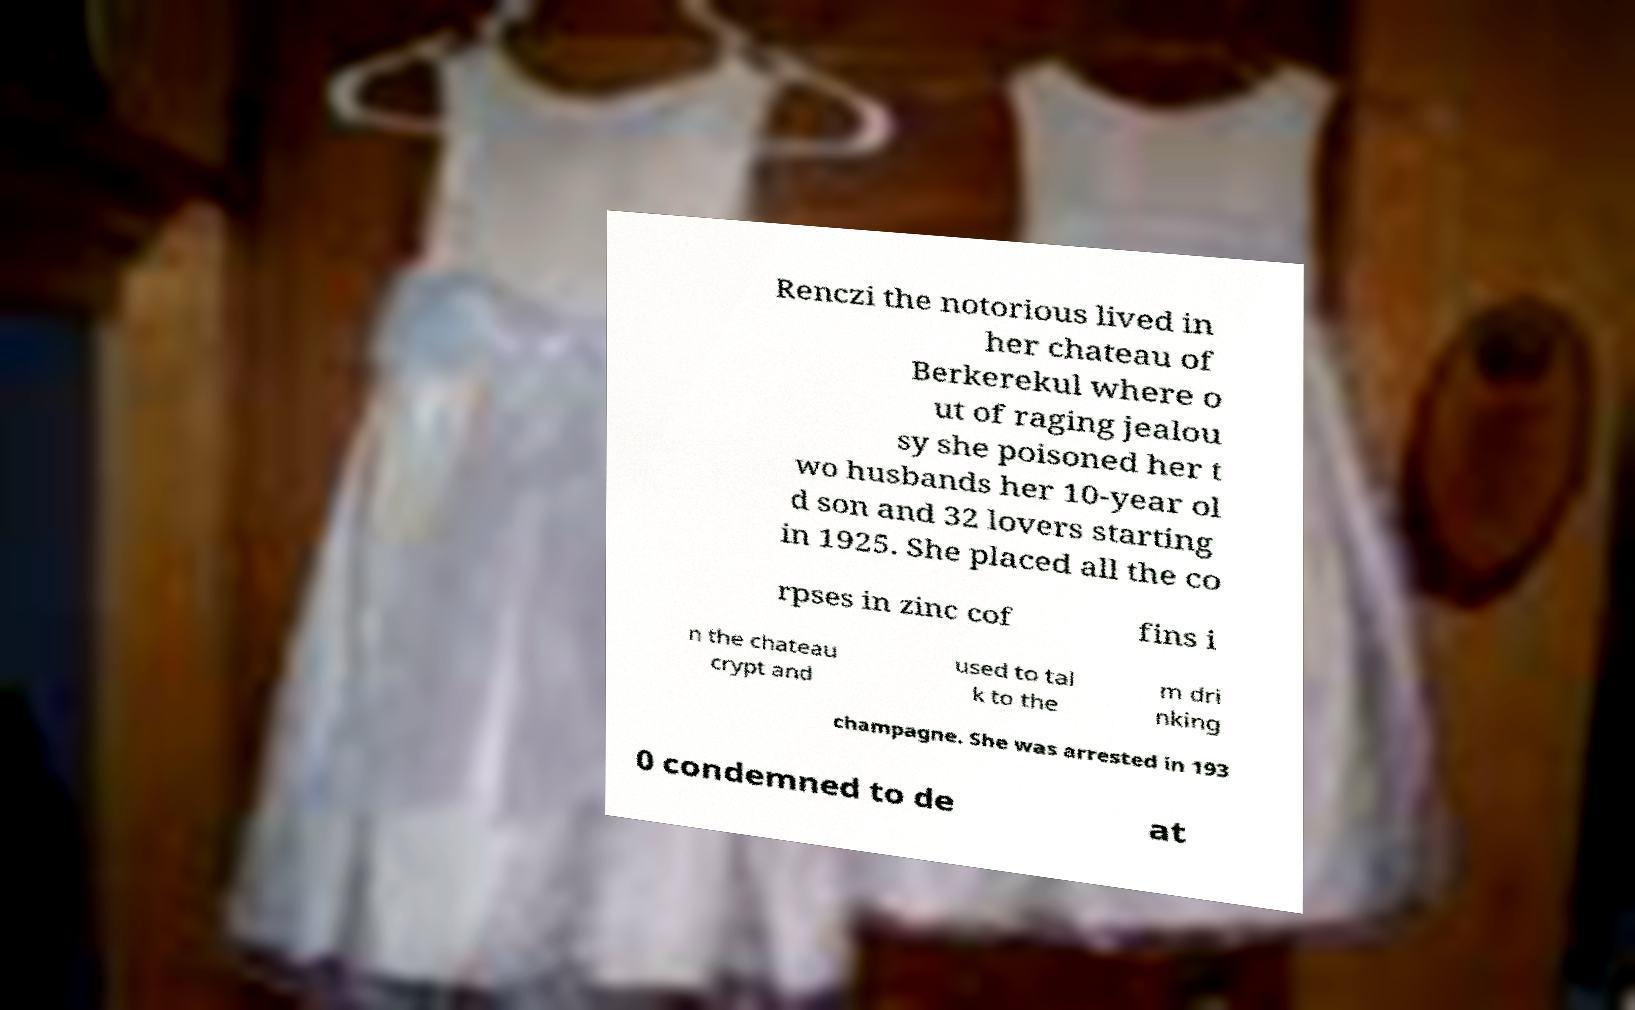What messages or text are displayed in this image? I need them in a readable, typed format. Renczi the notorious lived in her chateau of Berkerekul where o ut of raging jealou sy she poisoned her t wo husbands her 10-year ol d son and 32 lovers starting in 1925. She placed all the co rpses in zinc cof fins i n the chateau crypt and used to tal k to the m dri nking champagne. She was arrested in 193 0 condemned to de at 